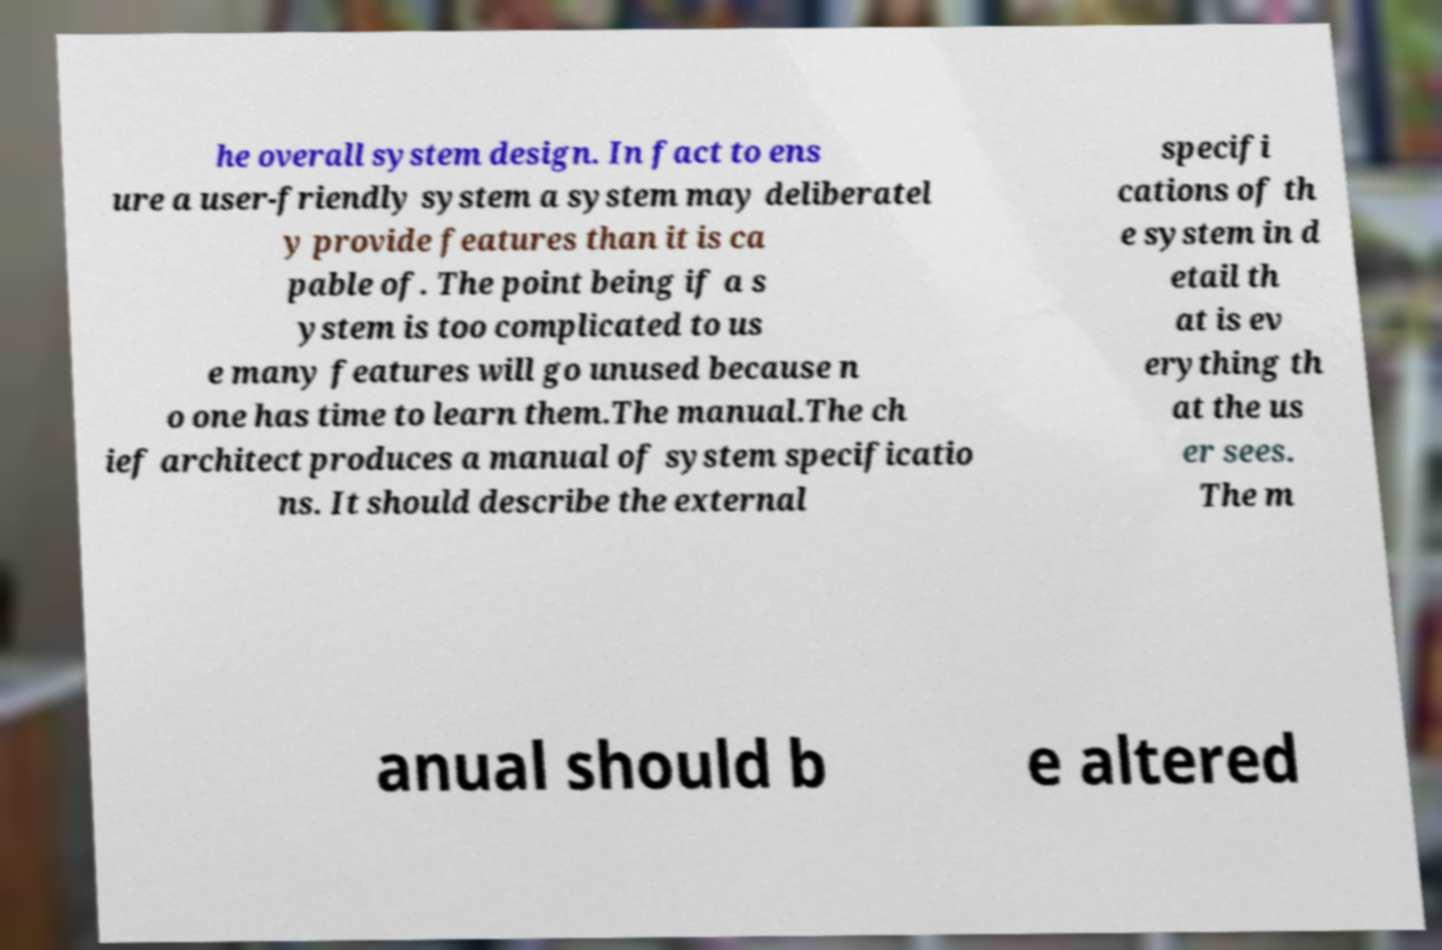I need the written content from this picture converted into text. Can you do that? he overall system design. In fact to ens ure a user-friendly system a system may deliberatel y provide features than it is ca pable of. The point being if a s ystem is too complicated to us e many features will go unused because n o one has time to learn them.The manual.The ch ief architect produces a manual of system specificatio ns. It should describe the external specifi cations of th e system in d etail th at is ev erything th at the us er sees. The m anual should b e altered 